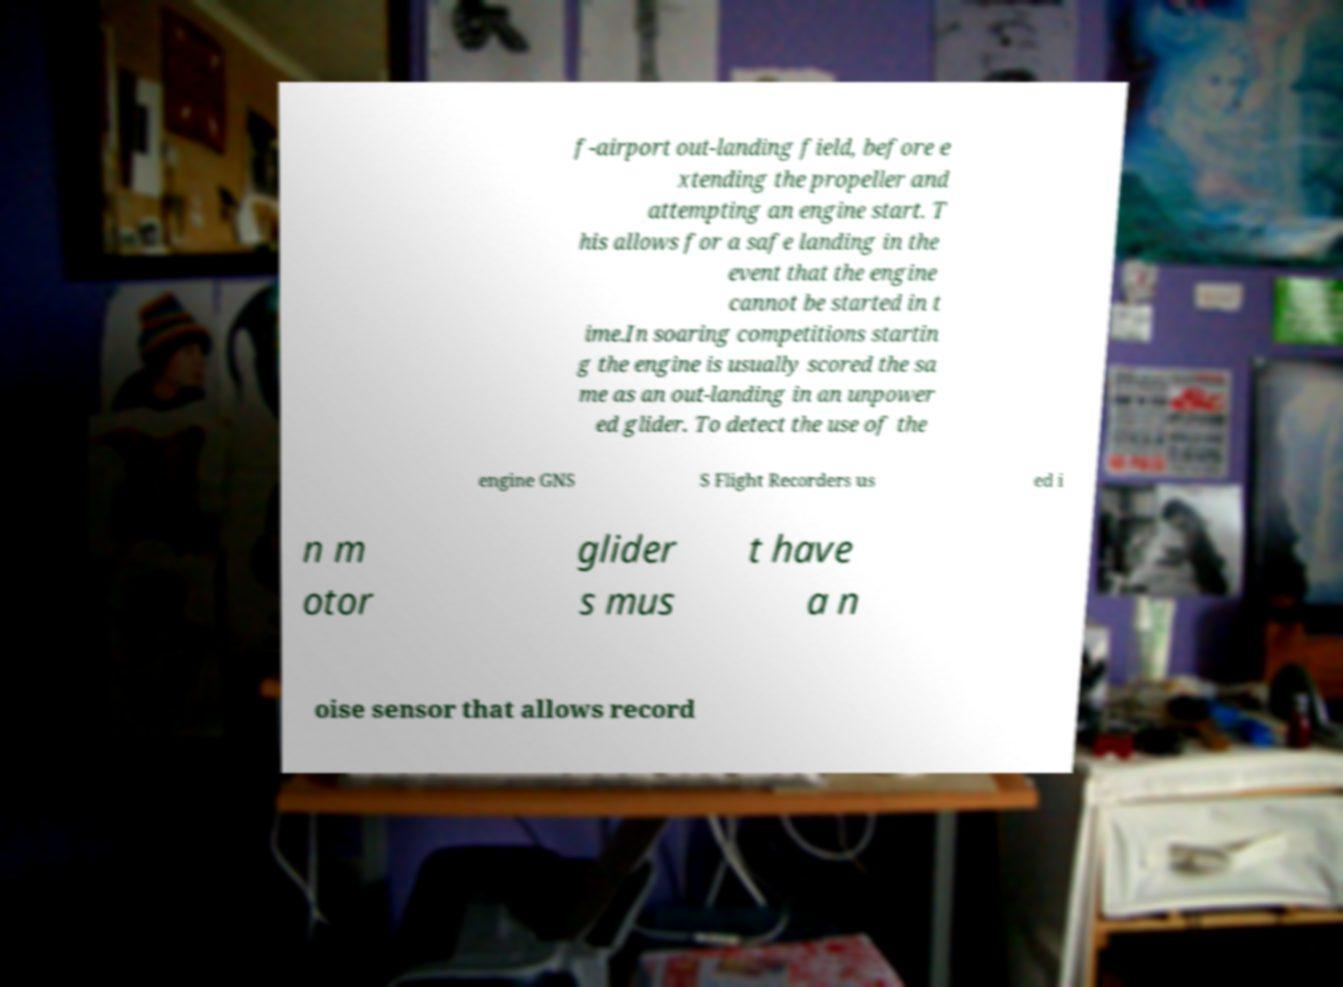Could you extract and type out the text from this image? f-airport out-landing field, before e xtending the propeller and attempting an engine start. T his allows for a safe landing in the event that the engine cannot be started in t ime.In soaring competitions startin g the engine is usually scored the sa me as an out-landing in an unpower ed glider. To detect the use of the engine GNS S Flight Recorders us ed i n m otor glider s mus t have a n oise sensor that allows record 